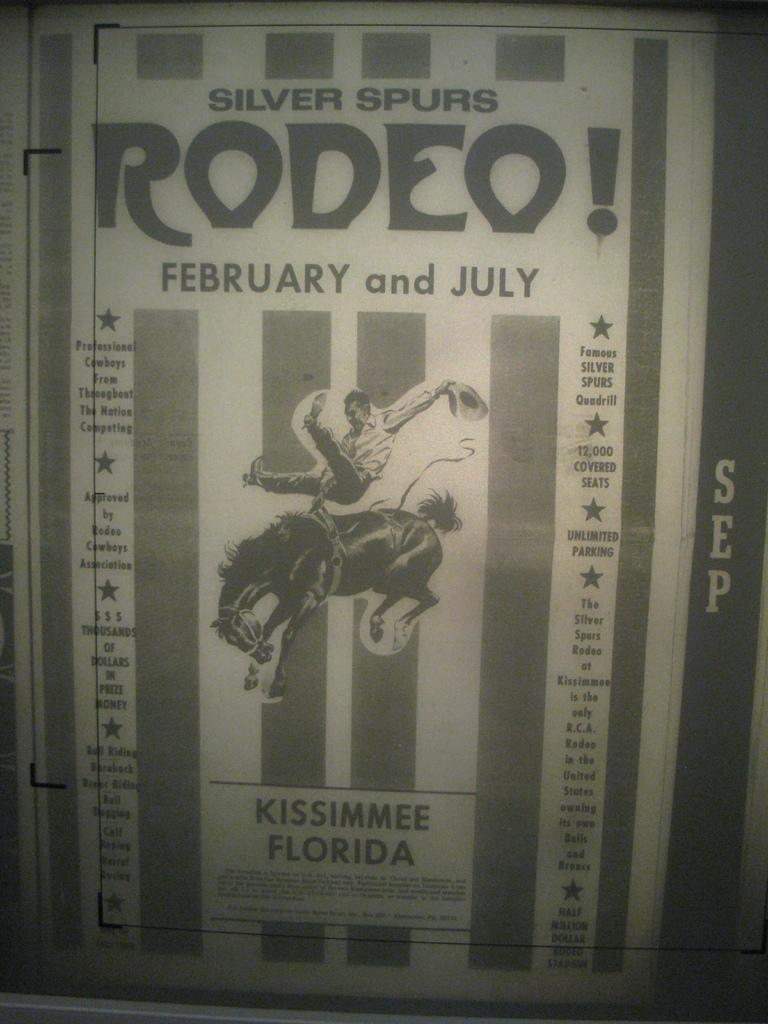Provide a one-sentence caption for the provided image. A monochrome rodeo poster advertises an event in Florida. 